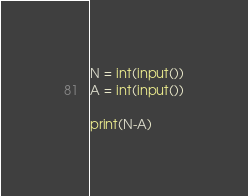Convert code to text. <code><loc_0><loc_0><loc_500><loc_500><_Python_>N = int(input())
A = int(input())

print(N-A)</code> 